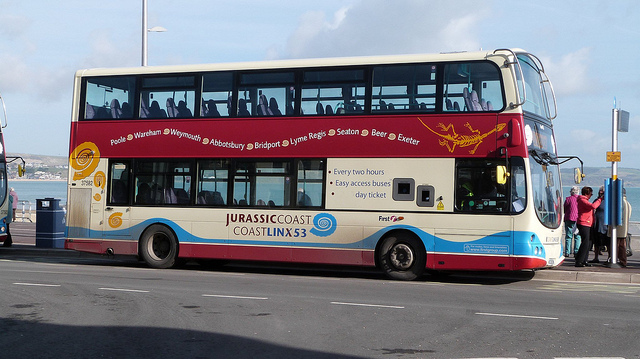<image>What are the ingredients in the advertisement on the side of the bus? It is ambiguous what the ingredients in the advertisement on the side of the bus are. What are the ingredients in the advertisement on the side of the bus? I don't know what are the ingredients in the advertisement on the side of the bus. It can be seen 'beer', 'food', 'jurassic coast', 'towns', 'pizza', or something else. 